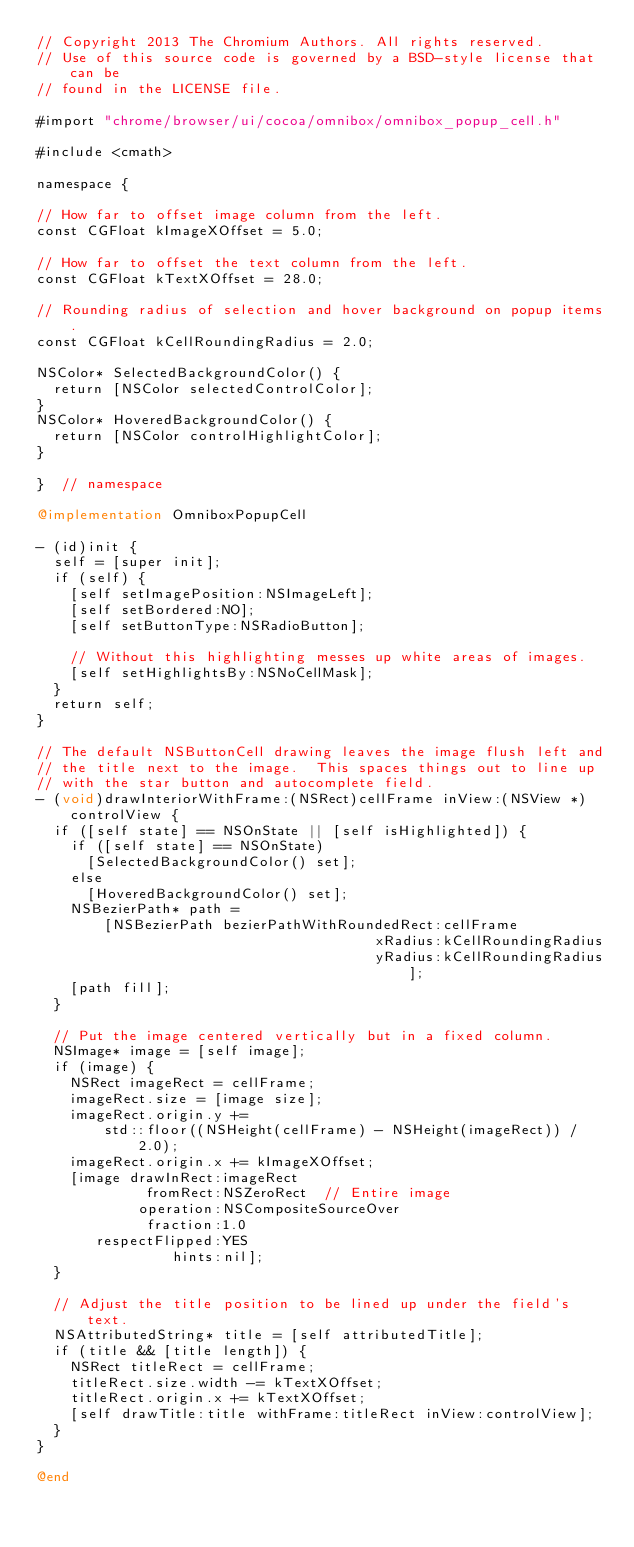<code> <loc_0><loc_0><loc_500><loc_500><_ObjectiveC_>// Copyright 2013 The Chromium Authors. All rights reserved.
// Use of this source code is governed by a BSD-style license that can be
// found in the LICENSE file.

#import "chrome/browser/ui/cocoa/omnibox/omnibox_popup_cell.h"

#include <cmath>

namespace {

// How far to offset image column from the left.
const CGFloat kImageXOffset = 5.0;

// How far to offset the text column from the left.
const CGFloat kTextXOffset = 28.0;

// Rounding radius of selection and hover background on popup items.
const CGFloat kCellRoundingRadius = 2.0;

NSColor* SelectedBackgroundColor() {
  return [NSColor selectedControlColor];
}
NSColor* HoveredBackgroundColor() {
  return [NSColor controlHighlightColor];
}

}  // namespace

@implementation OmniboxPopupCell

- (id)init {
  self = [super init];
  if (self) {
    [self setImagePosition:NSImageLeft];
    [self setBordered:NO];
    [self setButtonType:NSRadioButton];

    // Without this highlighting messes up white areas of images.
    [self setHighlightsBy:NSNoCellMask];
  }
  return self;
}

// The default NSButtonCell drawing leaves the image flush left and
// the title next to the image.  This spaces things out to line up
// with the star button and autocomplete field.
- (void)drawInteriorWithFrame:(NSRect)cellFrame inView:(NSView *)controlView {
  if ([self state] == NSOnState || [self isHighlighted]) {
    if ([self state] == NSOnState)
      [SelectedBackgroundColor() set];
    else
      [HoveredBackgroundColor() set];
    NSBezierPath* path =
        [NSBezierPath bezierPathWithRoundedRect:cellFrame
                                        xRadius:kCellRoundingRadius
                                        yRadius:kCellRoundingRadius];
    [path fill];
  }

  // Put the image centered vertically but in a fixed column.
  NSImage* image = [self image];
  if (image) {
    NSRect imageRect = cellFrame;
    imageRect.size = [image size];
    imageRect.origin.y +=
        std::floor((NSHeight(cellFrame) - NSHeight(imageRect)) / 2.0);
    imageRect.origin.x += kImageXOffset;
    [image drawInRect:imageRect
             fromRect:NSZeroRect  // Entire image
            operation:NSCompositeSourceOver
             fraction:1.0
       respectFlipped:YES
                hints:nil];
  }

  // Adjust the title position to be lined up under the field's text.
  NSAttributedString* title = [self attributedTitle];
  if (title && [title length]) {
    NSRect titleRect = cellFrame;
    titleRect.size.width -= kTextXOffset;
    titleRect.origin.x += kTextXOffset;
    [self drawTitle:title withFrame:titleRect inView:controlView];
  }
}

@end
</code> 